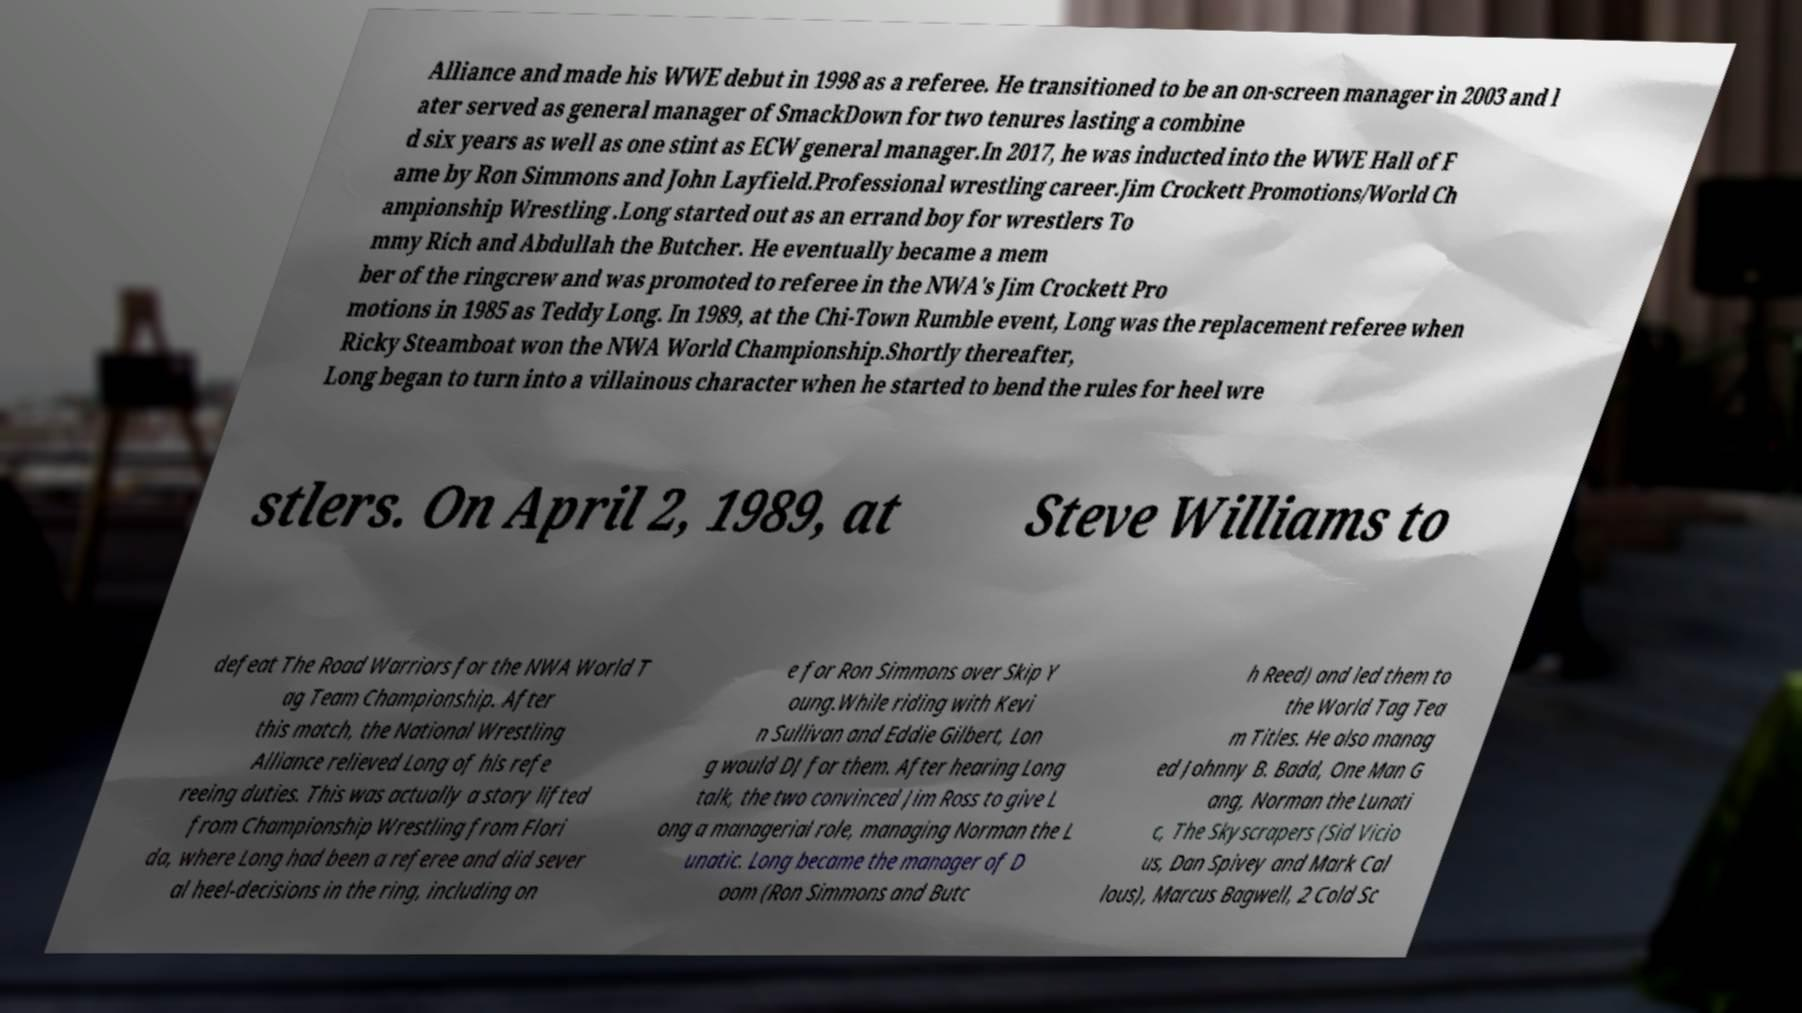Could you assist in decoding the text presented in this image and type it out clearly? Alliance and made his WWE debut in 1998 as a referee. He transitioned to be an on-screen manager in 2003 and l ater served as general manager of SmackDown for two tenures lasting a combine d six years as well as one stint as ECW general manager.In 2017, he was inducted into the WWE Hall of F ame by Ron Simmons and John Layfield.Professional wrestling career.Jim Crockett Promotions/World Ch ampionship Wrestling .Long started out as an errand boy for wrestlers To mmy Rich and Abdullah the Butcher. He eventually became a mem ber of the ringcrew and was promoted to referee in the NWA's Jim Crockett Pro motions in 1985 as Teddy Long. In 1989, at the Chi-Town Rumble event, Long was the replacement referee when Ricky Steamboat won the NWA World Championship.Shortly thereafter, Long began to turn into a villainous character when he started to bend the rules for heel wre stlers. On April 2, 1989, at Steve Williams to defeat The Road Warriors for the NWA World T ag Team Championship. After this match, the National Wrestling Alliance relieved Long of his refe reeing duties. This was actually a story lifted from Championship Wrestling from Flori da, where Long had been a referee and did sever al heel-decisions in the ring, including on e for Ron Simmons over Skip Y oung.While riding with Kevi n Sullivan and Eddie Gilbert, Lon g would DJ for them. After hearing Long talk, the two convinced Jim Ross to give L ong a managerial role, managing Norman the L unatic. Long became the manager of D oom (Ron Simmons and Butc h Reed) and led them to the World Tag Tea m Titles. He also manag ed Johnny B. Badd, One Man G ang, Norman the Lunati c, The Skyscrapers (Sid Vicio us, Dan Spivey and Mark Cal lous), Marcus Bagwell, 2 Cold Sc 